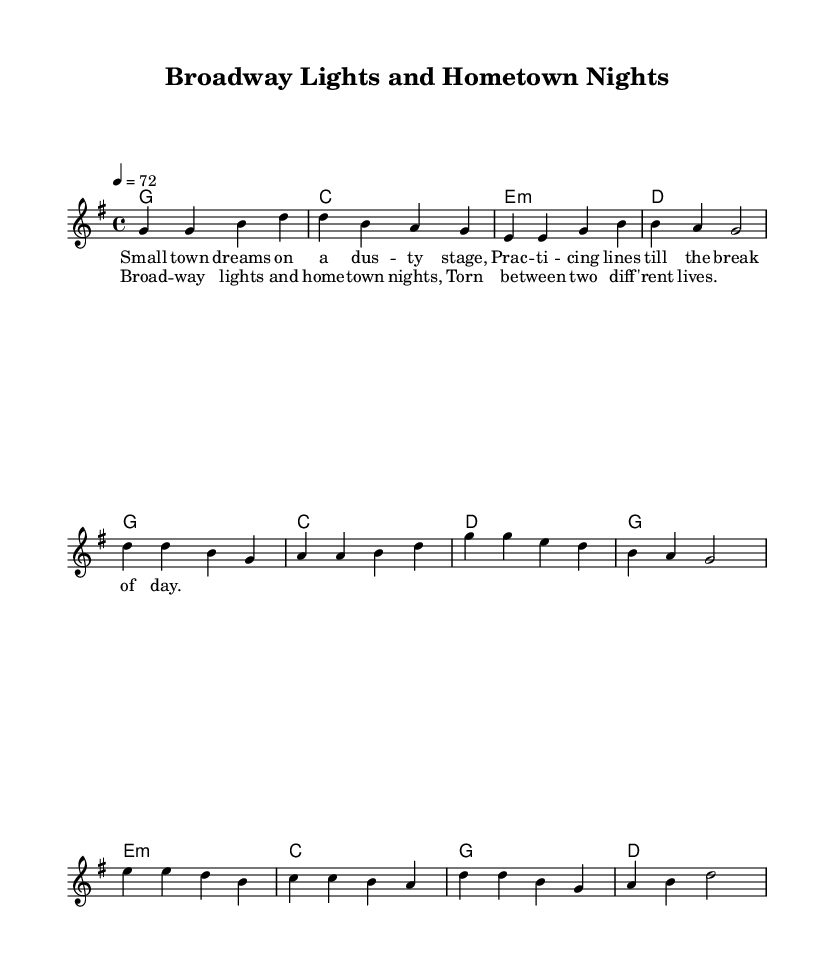What is the key signature of this music? The key signature is indicated at the beginning of the score, showing one sharp, which corresponds to G major.
Answer: G major What is the time signature of this piece? The time signature is written at the beginning of the score, noted as 4/4, meaning there are four beats per measure, and the quarter note gets one beat.
Answer: 4/4 What is the tempo marking for this piece? The tempo marking is found near the beginning. It is indicated as "4 = 72," meaning the quarter note should be played at a speed of 72 beats per minute.
Answer: 72 How many measures are in the verse? The verse consists of four measures, as indicated by the sequence of notes and rests grouped together.
Answer: 4 What is the lyrical theme explored in the chorus? The chorus reflects a conflict between the allure of Broadway and the comfort of hometown, as seen in the lyrics "Broadway lights and hometown nights, Torn between two different lives."
Answer: Conflict Which sections of music include lyrics? The lyrics are included in both the verse and the chorus, making them integral to understanding the song's narrative structure.
Answer: Verse and Chorus What musical elements contribute to the feeling of nostalgia in the ballad? The use of simple harmonies, reflective lyrics, and a slow tempo evokes a sense of longing and connection to small-town dreams contrasted with big-city aspirations.
Answer: Harmonies, Lyrics, Tempo 